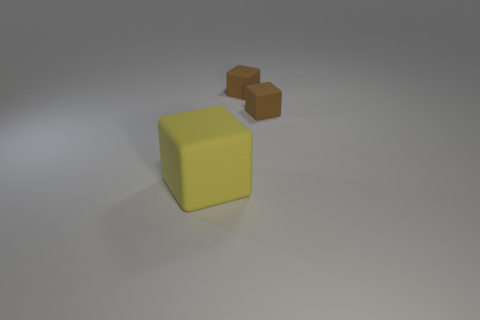What number of things are either objects that are behind the big yellow rubber thing or blocks that are to the right of the large matte cube?
Provide a short and direct response. 2. Are there fewer green balls than brown matte things?
Offer a terse response. Yes. What number of objects are big yellow objects or tiny matte objects?
Your response must be concise. 3. Is the number of yellow cubes on the right side of the big block less than the number of big yellow cubes?
Provide a succinct answer. Yes. Are there any small cylinders?
Offer a very short reply. No. Is there a big yellow object that has the same material as the big block?
Provide a short and direct response. No. What color is the big object?
Make the answer very short. Yellow. What number of other objects are the same shape as the big yellow matte thing?
Give a very brief answer. 2. Is there anything else that is the same size as the yellow rubber thing?
Provide a succinct answer. No. How many cubes are either large objects or matte things?
Your response must be concise. 3. 